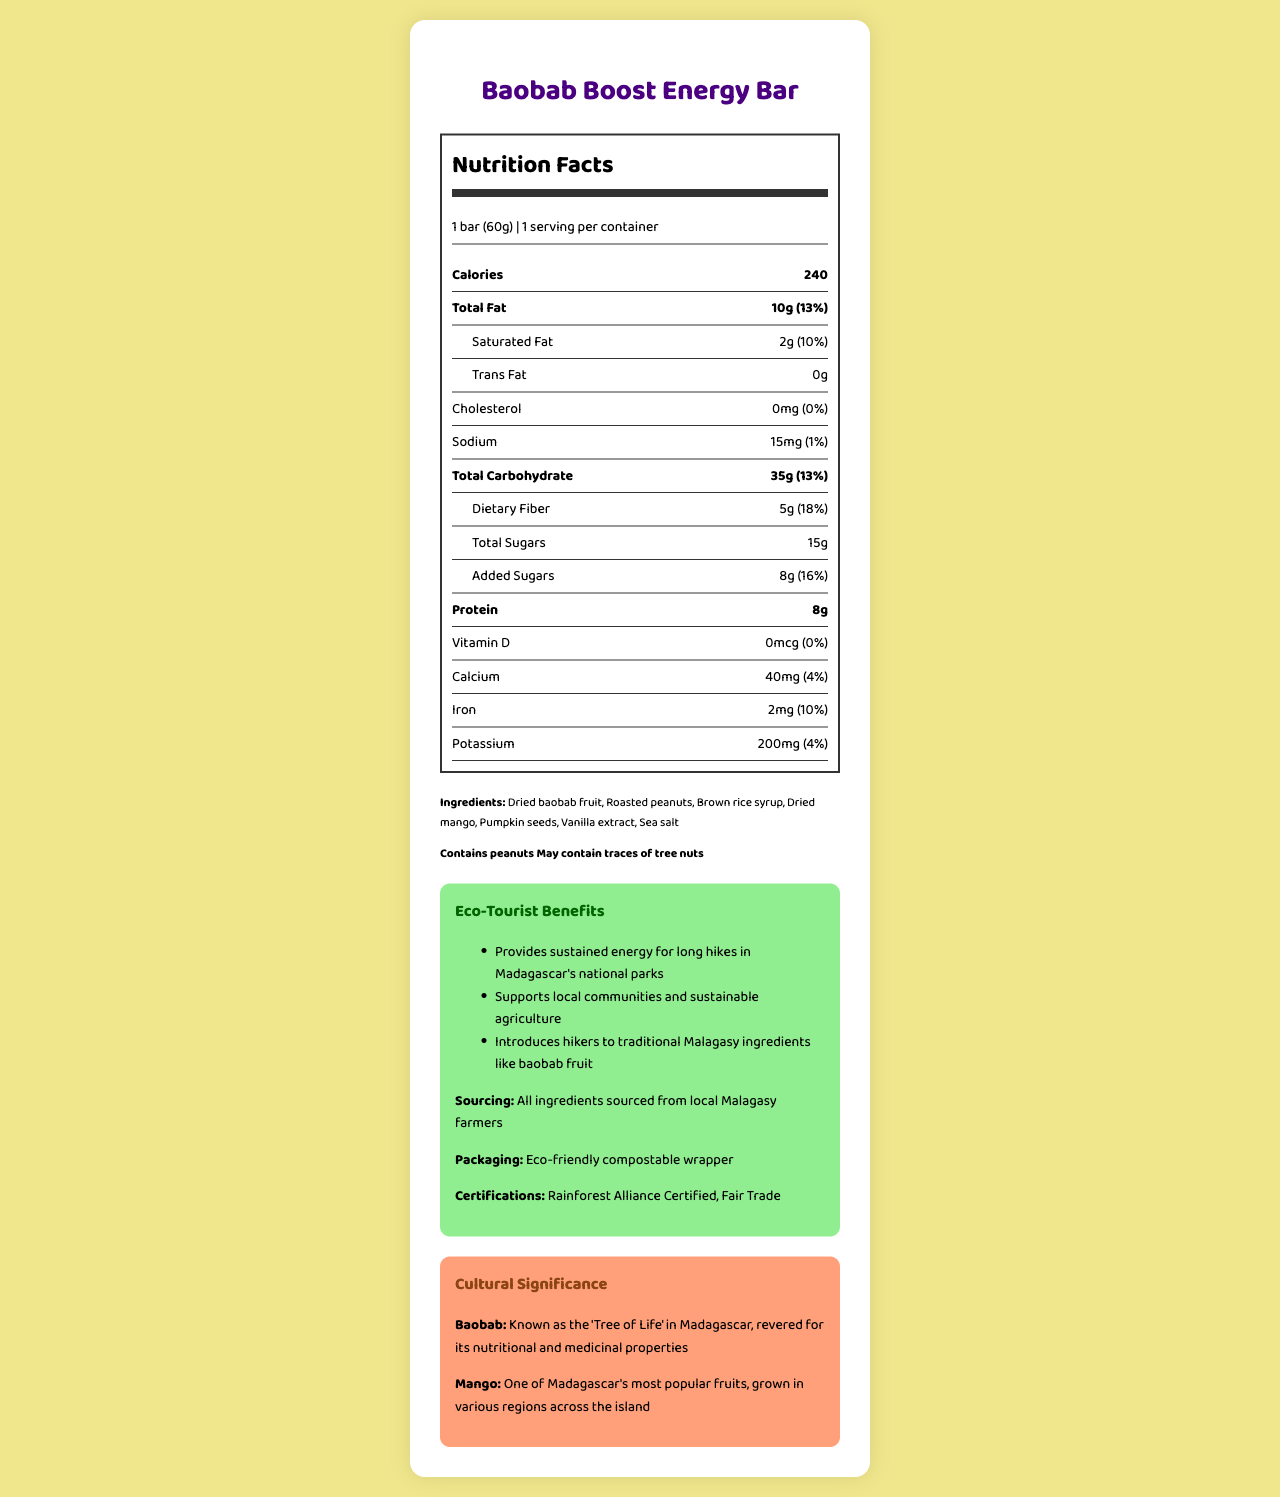what is the serving size of the Baobab Boost Energy Bar? The serving size is explicitly mentioned as 1 bar (60g).
Answer: 1 bar (60g) how many calories does one Baobab Boost Energy Bar contain? The document lists the calorie count directly under the nutrition facts.
Answer: 240 calories how much dietary fiber is in one serving? The nutritional label indicates 5g of dietary fiber per serving.
Answer: 5g what is the amount of protein in the energy bar? The protein content is listed as 8g in the nutrition facts section.
Answer: 8g are there any allergens in the Baobab Boost Energy Bar? If yes, what are they? The document lists the allergens under the 'Allergens' section.
Answer: Contains peanuts, May contain traces of tree nuts what is the percentage of daily value for saturated fat in the energy bar? The daily value percentage for saturated fat is directly listed as 10%.
Answer: 10% how much iron does one bar contain? The amount of iron is specified as 2mg in the nutrition section.
Answer: 2mg which traditional Malagasy ingredient is highlighted in the Baobab Boost Energy Bar? A. Vanilla B. Rice C. Baobab fruit D. Cocoa The eco-tourist benefits mention introducing hikers to traditional Malagasy ingredients like baobab fruit.
Answer: C which of the following certifications does the Baobab Boost Energy Bar have? A. Organic Certified B. Rainforest Alliance Certified C. Non-GMO Project Verified D. Kosher Certified The document lists "Rainforest Alliance Certified" as one of its certifications.
Answer: B is the wrapper of the Baobab Boost Energy Bar eco-friendly? The additional information section states that the packaging is an eco-friendly compostable wrapper.
Answer: Yes does this energy bar contain any cholesterol? The nutritional section states 0mg of cholesterol with 0% daily value.
Answer: No what is the main idea of the document? The document includes comprehensive data like nutrition facts, sourcing, packaging, cultural significance of ingredients, and allergen information which collectively highlight the benefits of the energy bar.
Answer: The document provides detailed nutritional information, ingredient list, and eco-friendly features of the Baobab Boost Energy Bar, designed for eco-tourists hiking in Madagascar. It emphasizes local sourcing, sustainability, and the inclusion of traditional Malagasy ingredients. how much vitamin D is in the Baobab Boost Energy Bar? The amount of vitamin D is stated as 0mcg in the nutritional information.
Answer: 0mcg how should the Baobab Boost Energy Bar be stored? The storage information is provided in the additional info section.
Answer: Store in a cool, dry place can the exact protein content of the Baobab Boost Energy Bar be determined from the document? The document specifies that the protein content is 8g.
Answer: Yes which fruit used in the Baobab Boost Energy Bar is one of Madagascar's most popular fruits? The cultural significance section mentions mango as one of Madagascar's most popular fruits.
Answer: Mango what is the purpose of the Baobab Boost Energy Bar packaging? The additional information section specifies that the packaging is eco-friendly and compostable.
Answer: The packaging is eco-friendly compostable wrapper is the Baobab Boost Energy Bar high in trans fat? The document states that the energy bar has 0g of trans fat.
Answer: No does the Baobab Boost Energy Bar support local communities? One of the eco-tourist benefits mentions that the bar supports local communities and sustainable agriculture.
Answer: Yes what is the expiry duration for the Baobab Boost Energy Bar? The expiration section in the additional info specifies this detail.
Answer: Best consumed within 6 months of production 